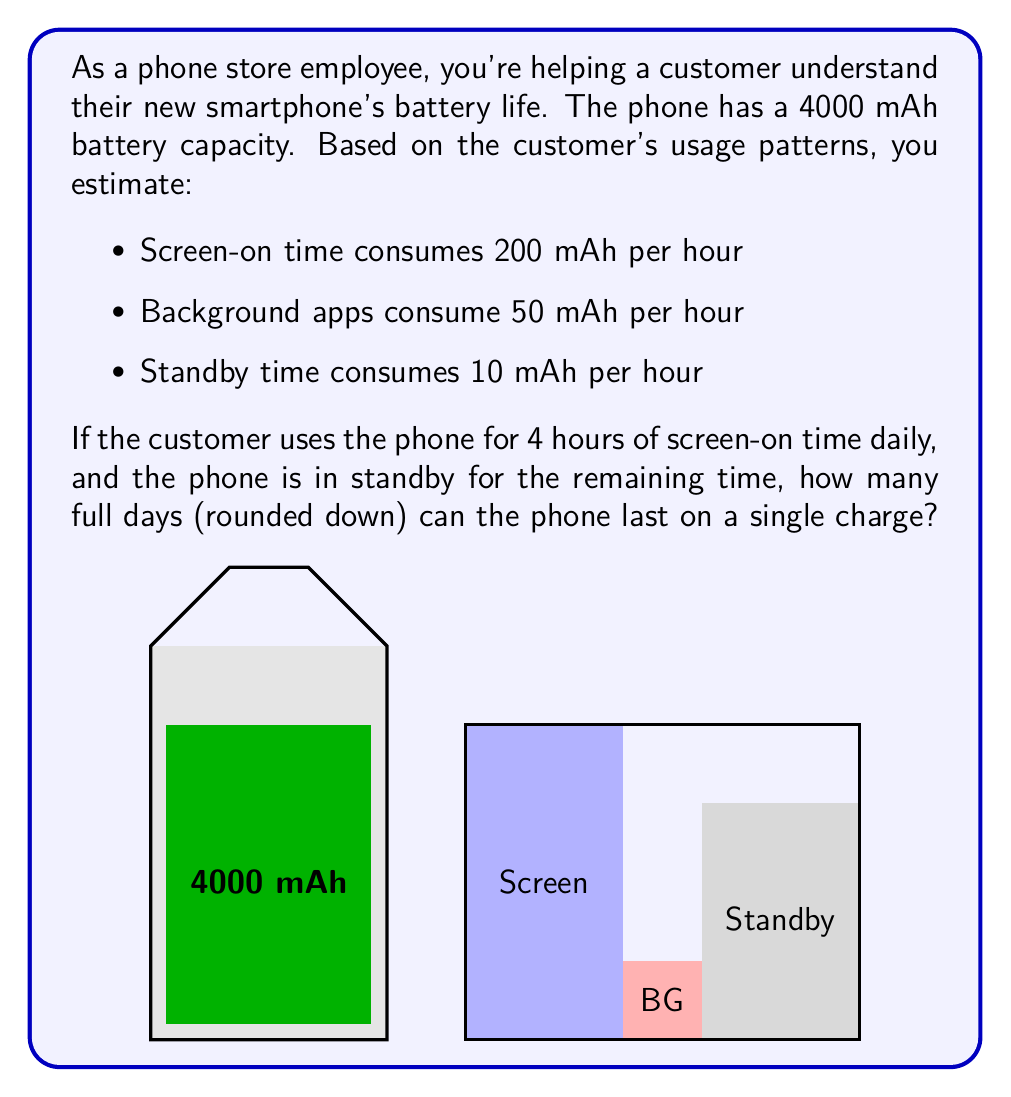Can you answer this question? Let's break this down step-by-step:

1) First, let's calculate the daily battery consumption:

   Screen-on time: $4 \text{ hours} \times 200 \text{ mAh/hour} = 800 \text{ mAh}$
   Background apps (24 hours): $24 \text{ hours} \times 50 \text{ mAh/hour} = 1200 \text{ mAh}$
   Standby time (20 hours, as 4 hours are screen-on): $20 \text{ hours} \times 10 \text{ mAh/hour} = 200 \text{ mAh}$

2) Total daily consumption:
   $$800 + 1200 + 200 = 2200 \text{ mAh}$$

3) Now, let's see how many days the 4000 mAh battery can last:
   $$\text{Days} = \frac{\text{Battery Capacity}}{\text{Daily Consumption}} = \frac{4000 \text{ mAh}}{2200 \text{ mAh/day}}$$

4) Calculating:
   $$\frac{4000}{2200} \approx 1.8181... \text{ days}$$

5) Rounding down to full days as requested:
   $$\lfloor 1.8181... \rfloor = 1 \text{ day}$$

Therefore, the phone can last 1 full day on a single charge with the given usage pattern.
Answer: 1 day 